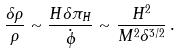<formula> <loc_0><loc_0><loc_500><loc_500>\frac { \delta \rho } { \rho } \sim \frac { H \delta \pi _ { H } } { \dot { \phi } } \sim \frac { H ^ { 2 } } { M ^ { 2 } \delta ^ { 3 / 2 } } \, .</formula> 